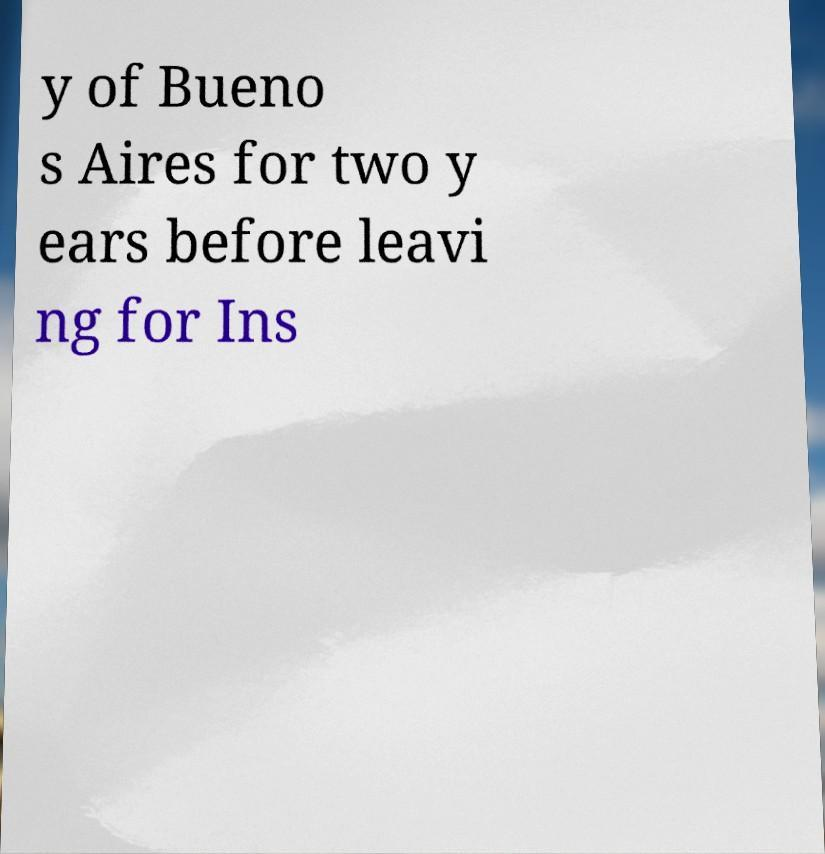Please identify and transcribe the text found in this image. y of Bueno s Aires for two y ears before leavi ng for Ins 